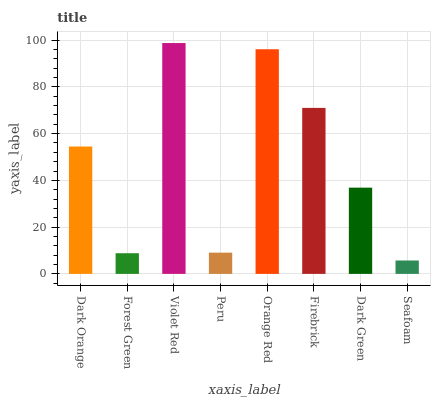Is Seafoam the minimum?
Answer yes or no. Yes. Is Violet Red the maximum?
Answer yes or no. Yes. Is Forest Green the minimum?
Answer yes or no. No. Is Forest Green the maximum?
Answer yes or no. No. Is Dark Orange greater than Forest Green?
Answer yes or no. Yes. Is Forest Green less than Dark Orange?
Answer yes or no. Yes. Is Forest Green greater than Dark Orange?
Answer yes or no. No. Is Dark Orange less than Forest Green?
Answer yes or no. No. Is Dark Orange the high median?
Answer yes or no. Yes. Is Dark Green the low median?
Answer yes or no. Yes. Is Violet Red the high median?
Answer yes or no. No. Is Violet Red the low median?
Answer yes or no. No. 